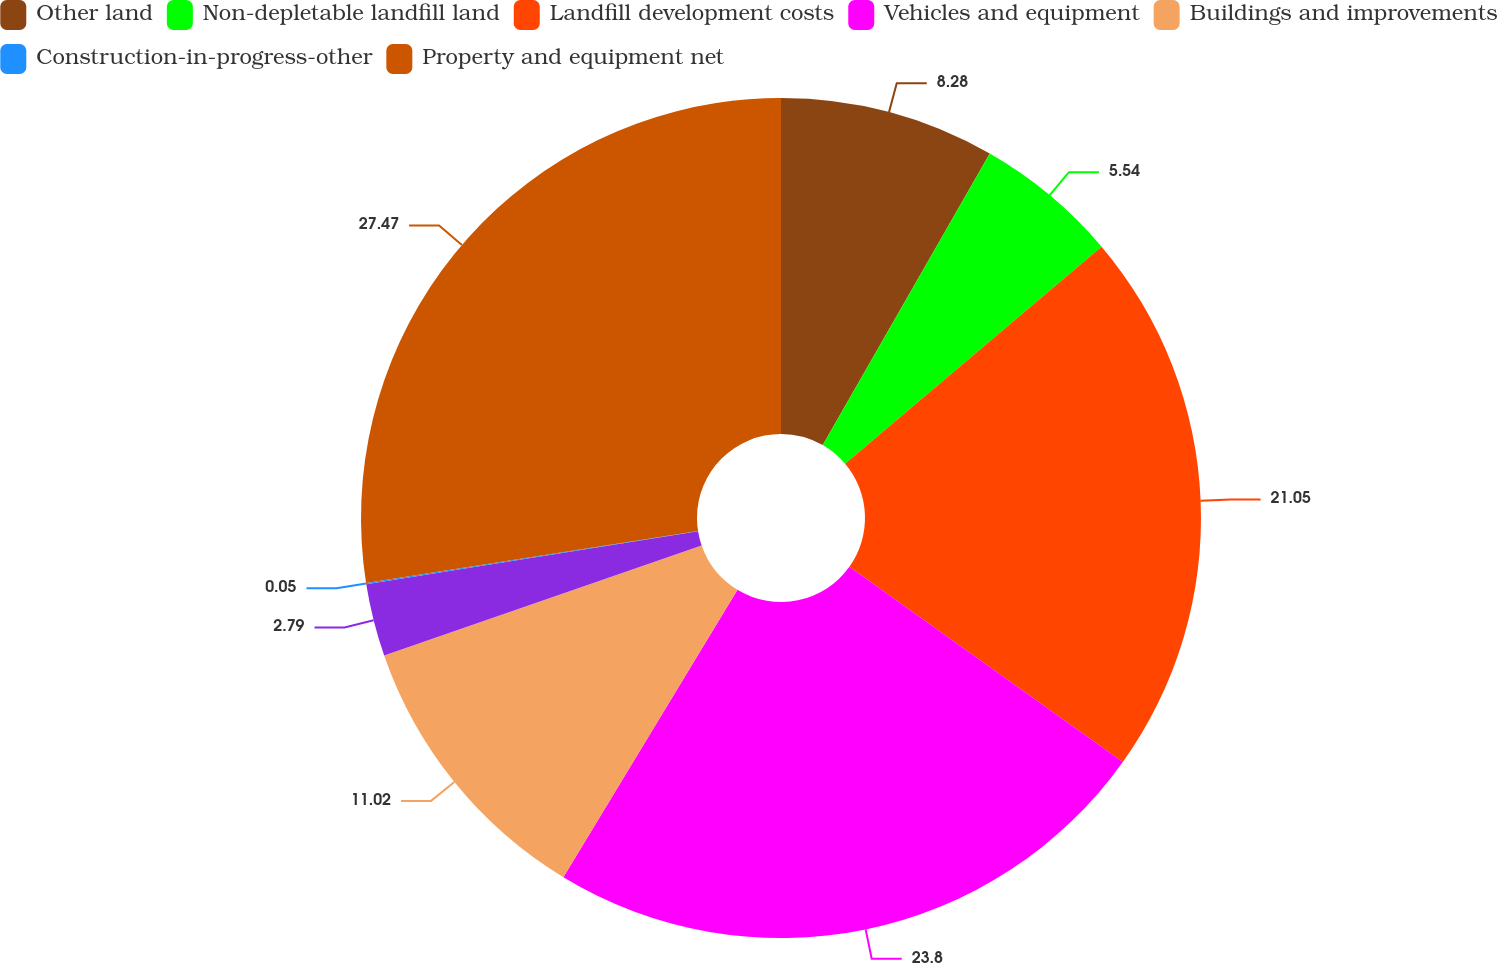<chart> <loc_0><loc_0><loc_500><loc_500><pie_chart><fcel>Other land<fcel>Non-depletable landfill land<fcel>Landfill development costs<fcel>Vehicles and equipment<fcel>Buildings and improvements<fcel>Unnamed: 5<fcel>Construction-in-progress-other<fcel>Property and equipment net<nl><fcel>8.28%<fcel>5.54%<fcel>21.05%<fcel>23.8%<fcel>11.02%<fcel>2.79%<fcel>0.05%<fcel>27.47%<nl></chart> 